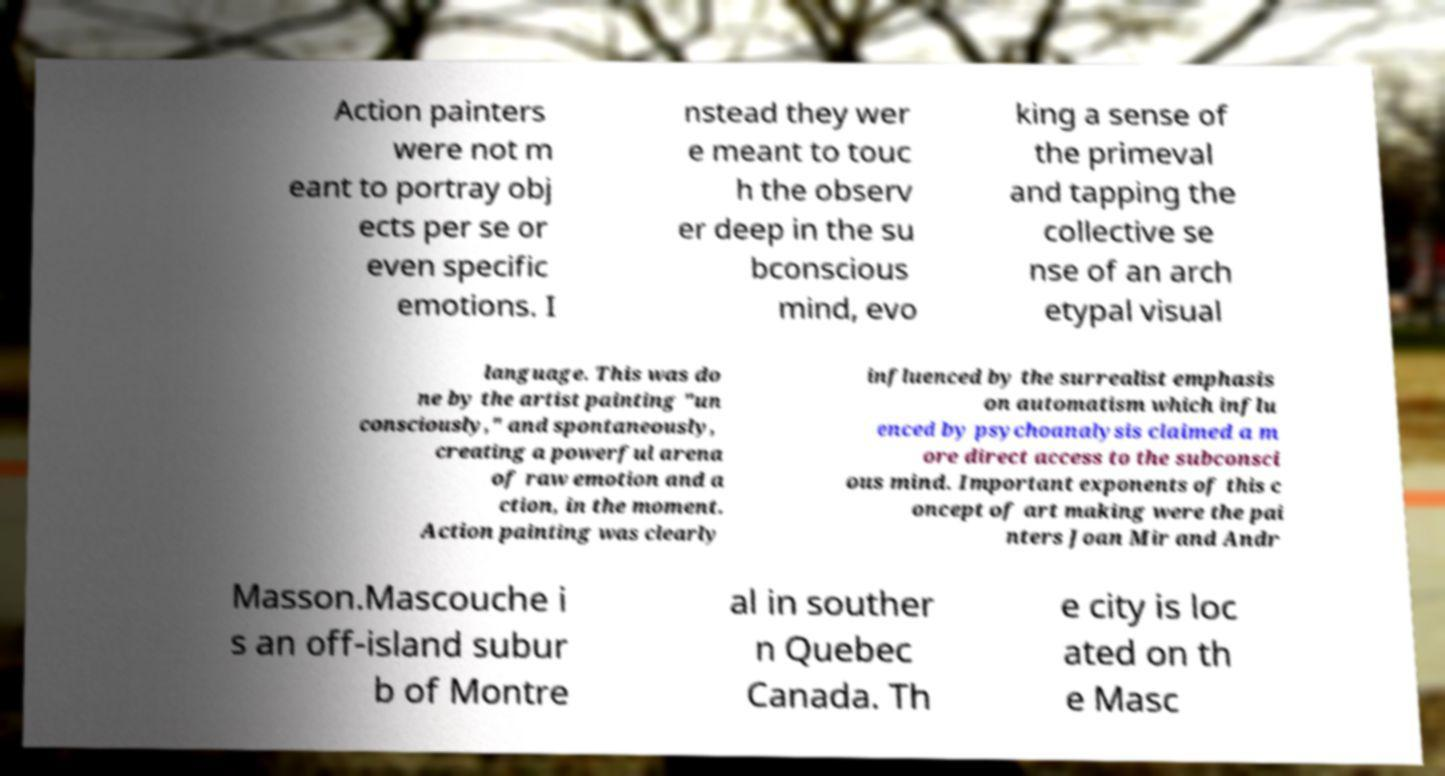Could you assist in decoding the text presented in this image and type it out clearly? Action painters were not m eant to portray obj ects per se or even specific emotions. I nstead they wer e meant to touc h the observ er deep in the su bconscious mind, evo king a sense of the primeval and tapping the collective se nse of an arch etypal visual language. This was do ne by the artist painting "un consciously," and spontaneously, creating a powerful arena of raw emotion and a ction, in the moment. Action painting was clearly influenced by the surrealist emphasis on automatism which influ enced by psychoanalysis claimed a m ore direct access to the subconsci ous mind. Important exponents of this c oncept of art making were the pai nters Joan Mir and Andr Masson.Mascouche i s an off-island subur b of Montre al in souther n Quebec Canada. Th e city is loc ated on th e Masc 